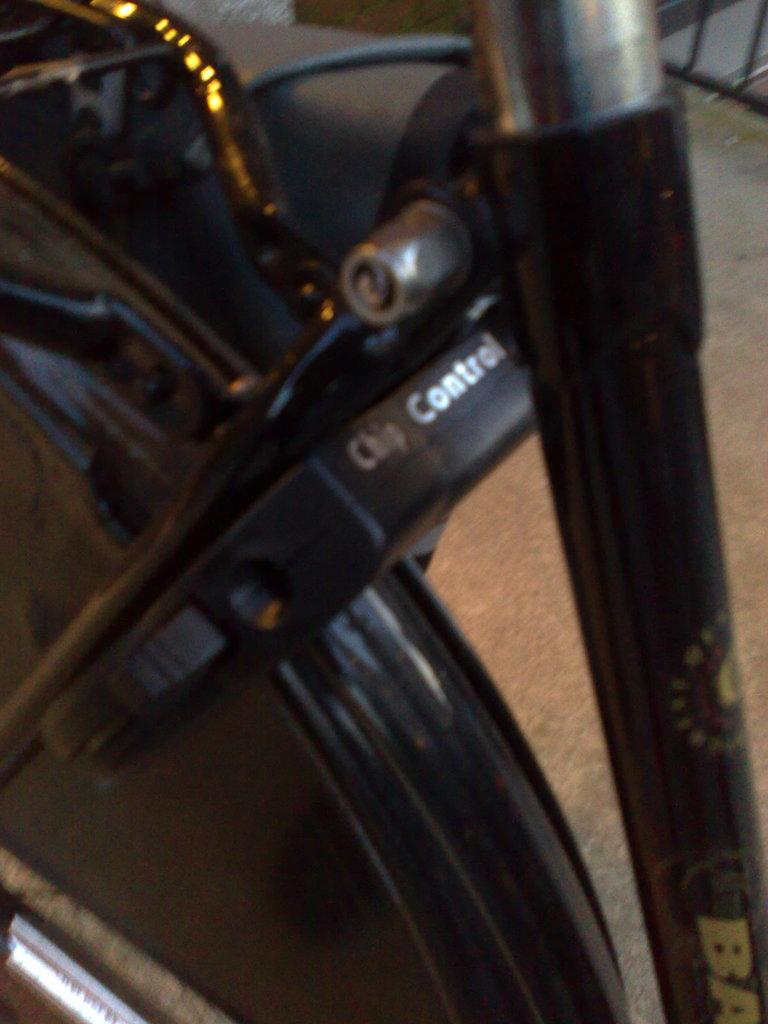What is the main subject of the image? There is a vehicle in the image. Can you describe the vehicle's position or location? The vehicle is on a surface. What decision did the sugar make in the image? There is no sugar present in the image, so no decision can be made by it. 